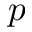<formula> <loc_0><loc_0><loc_500><loc_500>p</formula> 